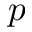<formula> <loc_0><loc_0><loc_500><loc_500>p</formula> 